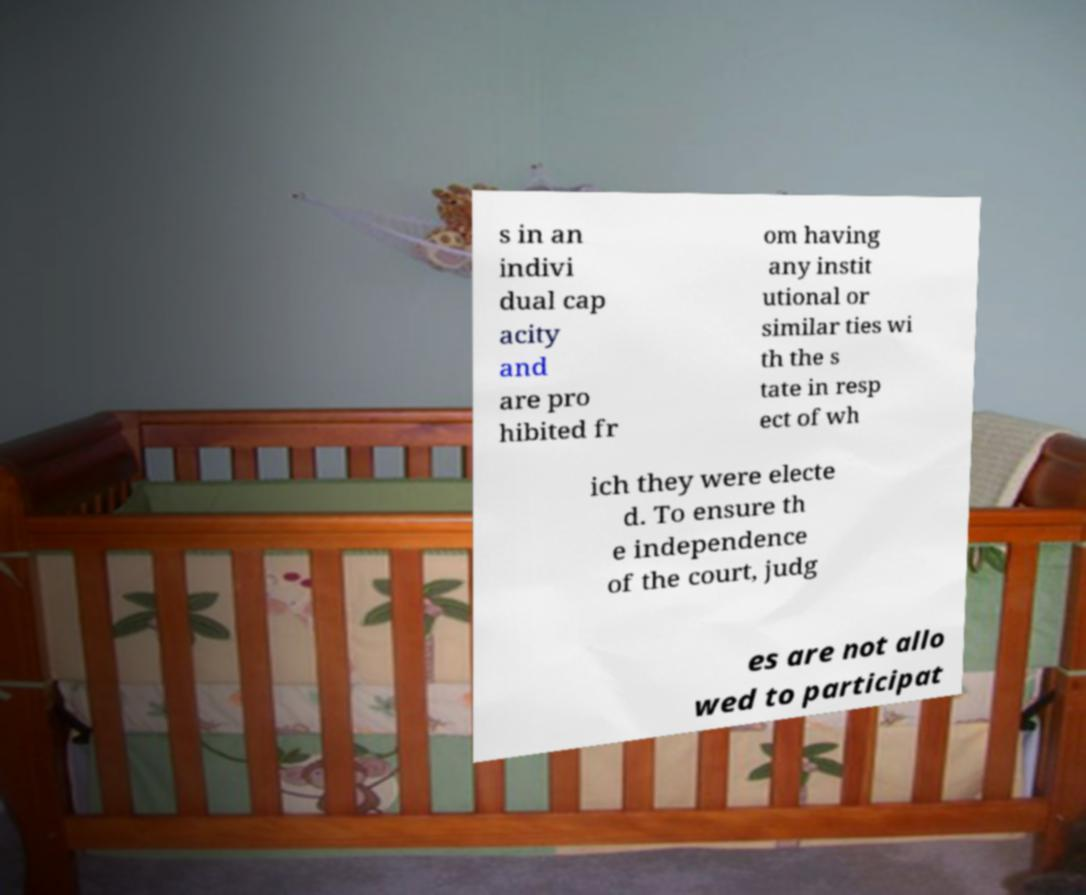I need the written content from this picture converted into text. Can you do that? s in an indivi dual cap acity and are pro hibited fr om having any instit utional or similar ties wi th the s tate in resp ect of wh ich they were electe d. To ensure th e independence of the court, judg es are not allo wed to participat 